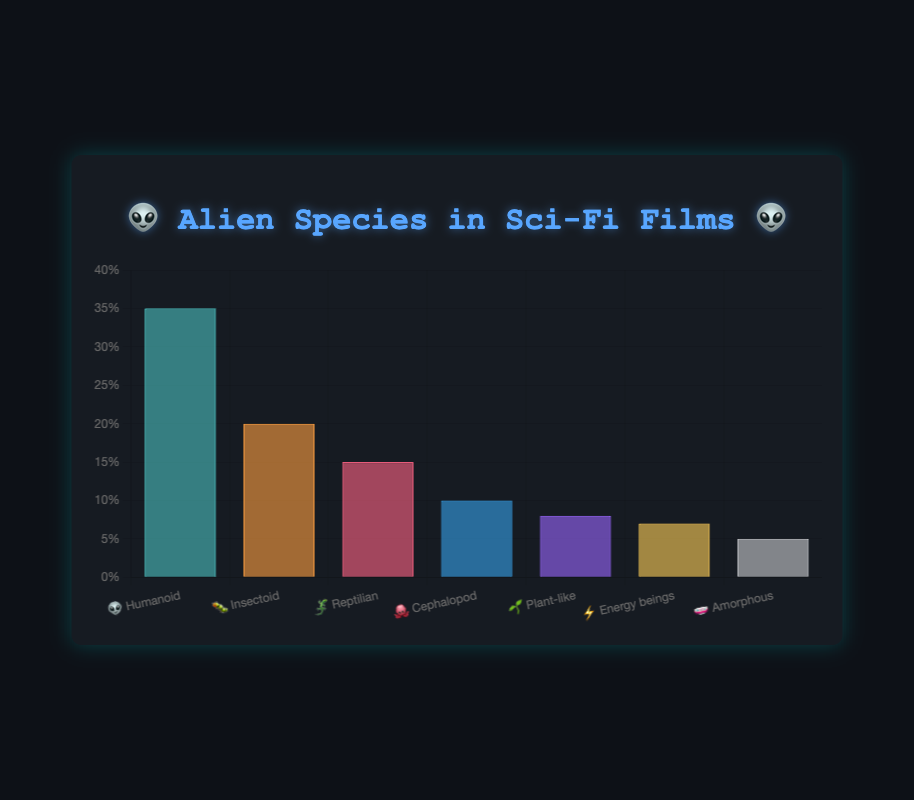what is the title of the chart? The title of the chart is clearly displayed at the top of the figure. It reads "👽 Alien Species in Sci-Fi Films 👽".
Answer: 👽 Alien Species in Sci-Fi Films 👽 what is the percentage of cephalopod aliens? To find the percentage of cephalopod aliens, locate the bar labeled "🐙 Cephalopod". The height of this bar indicates that cephalopod aliens make up 10% of the dataset.
Answer: 10% how many more humanoid aliens are there compared to plant-like aliens? First, note the percentages of humanoid (35%) and plant-like (8%) aliens. Subtract the percentage of plant-like aliens from the percentage of humanoid aliens: 35% - 8% = 27%. Thus, there are 27% more humanoid aliens compared to plant-like aliens.
Answer: 27% which type of alien has the lowest representation in sci-fi films? The type of alien with the lowest representation is found by identifying the shortest bar. The shortest bar corresponds to "🧫 Amorphous", with a value of 5%.
Answer: Amorphous what is the combined percentage of insectoid and reptilian aliens? To find the combined percentage of insectoid and reptilian aliens, add the percentages of insectoid (20%) and reptilian (15%) aliens: 20% + 15% = 35%.
Answer: 35% is the percentage of energy beings greater or less than plant-like aliens? Compare the percentage of energy beings (7%) with the percentage of plant-like aliens (8%). Since 7% is less than 8%, the percentage of energy beings is less than that of plant-like aliens.
Answer: Less how many species types have a percentage lower than 10%? To determine how many species types have a percentage lower than 10%, identify those types on the chart. The types are cephalopod (10%), plant-like (8%), energy beings (7%), and amorphous (5%). There are 3 types below 10%: plant-like, energy beings, and amorphous.
Answer: 3 which alien type has the second-highest representation? To find the second-highest representation, look for the second tallest bar. The tallest bar is humanoid (35%), and the second is insectoid (20%). Therefore, the insectoid type has the second-highest representation.
Answer: Insectoid considering the data points, what is the average percentage of all alien species types? To find the average percentage, add the values of all species types and divide by the number of types: (35% + 20% + 15% + 10% + 8% + 7% + 5%) / 7 = 100% / 7 ≈ 14.29%.
Answer: 14.29% what is the range of the percentages shown on the chart? The range is calculated by subtracting the smallest percentage from the largest. The largest percentage is 35% (humanoid) and the smallest is 5% (amorphous): 35% - 5% = 30%.
Answer: 30% 